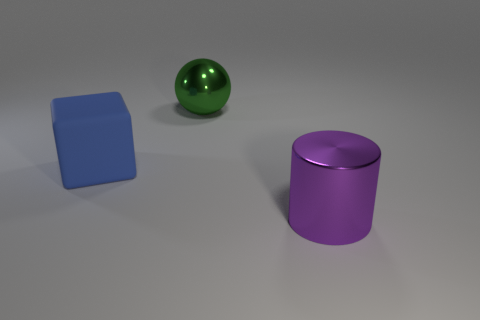Could you estimate the relative sizes of the objects based on this image? Based on the image, the large purple cylinder appears to be the tallest object, with its height exceeding its diameter. The green sphere's diameter looks smaller than the height of the cylinder but larger than the side of the blue cube. Lastly, the blue cube seems to have equal dimensions on all sides, making it the smallest in terms of volume. 